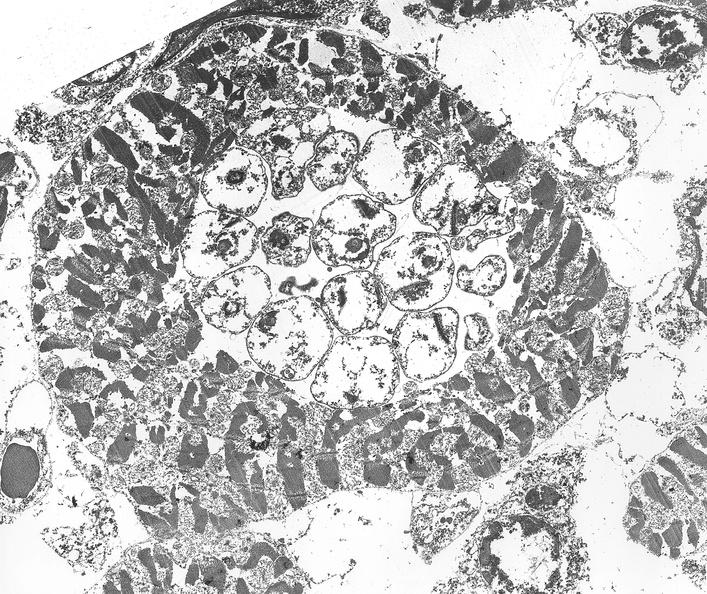s cardiovascular present?
Answer the question using a single word or phrase. Yes 